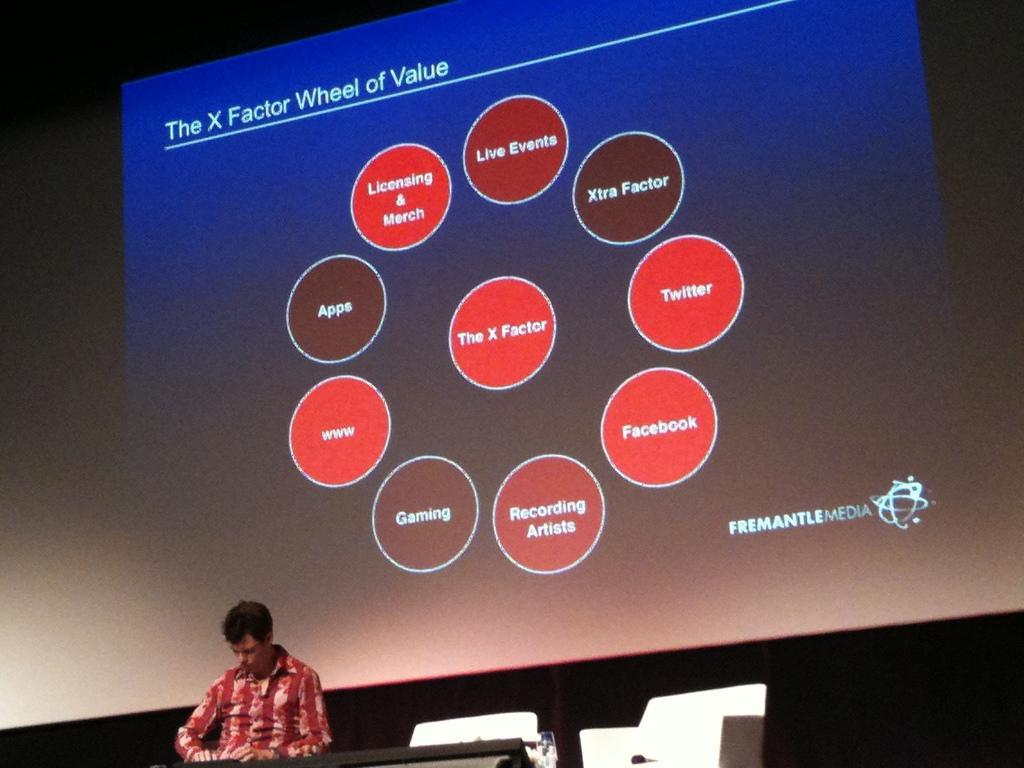In one or two sentences, can you explain what this image depicts? In this image we can see a man wearing red shirt is siting on the chair. This is the projector screen. 